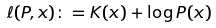<formula> <loc_0><loc_0><loc_500><loc_500>\ell ( P , x ) \colon = K ( x ) + \log P ( x )</formula> 